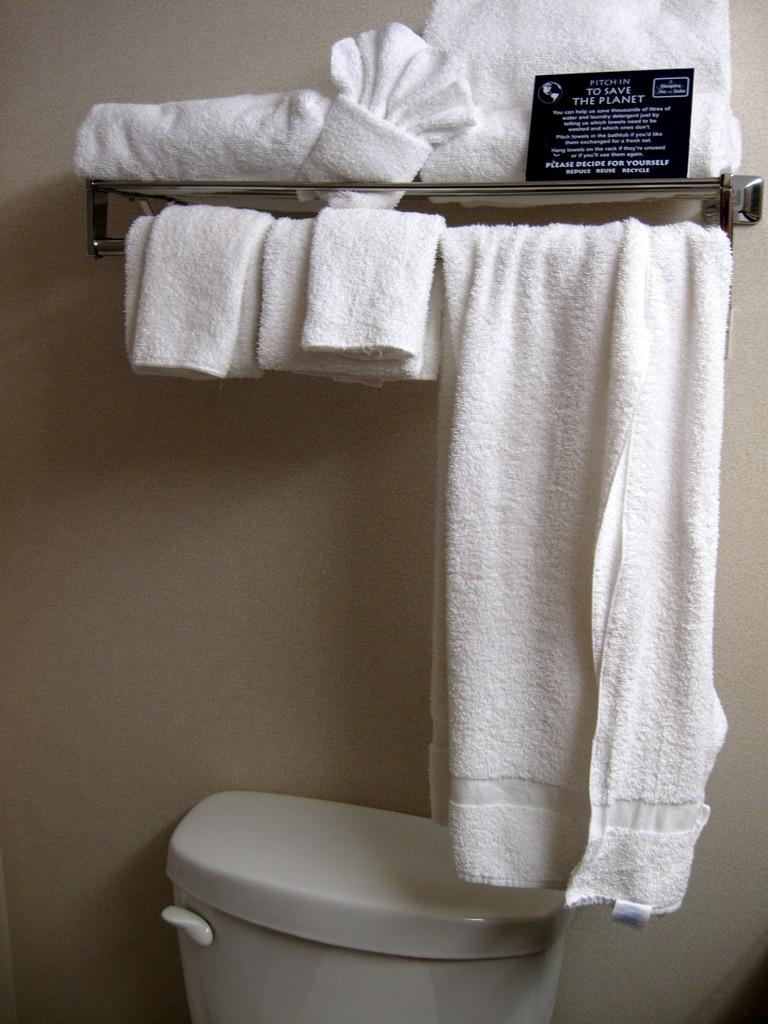What type of items are present on a stand in the image? There are napkins and towels on a stand in the image. What is the color of the napkins and towels in the image? The napkins and towels in the image are white in color. What other item can be seen in the image related to a bathroom? There is a flush tank in the image. What is the background of the image? There is a wall visible in the image. Can you see any yams being peeled on the edge of the wall in the image? No, there are no yams or any peeling activity visible in the image. 